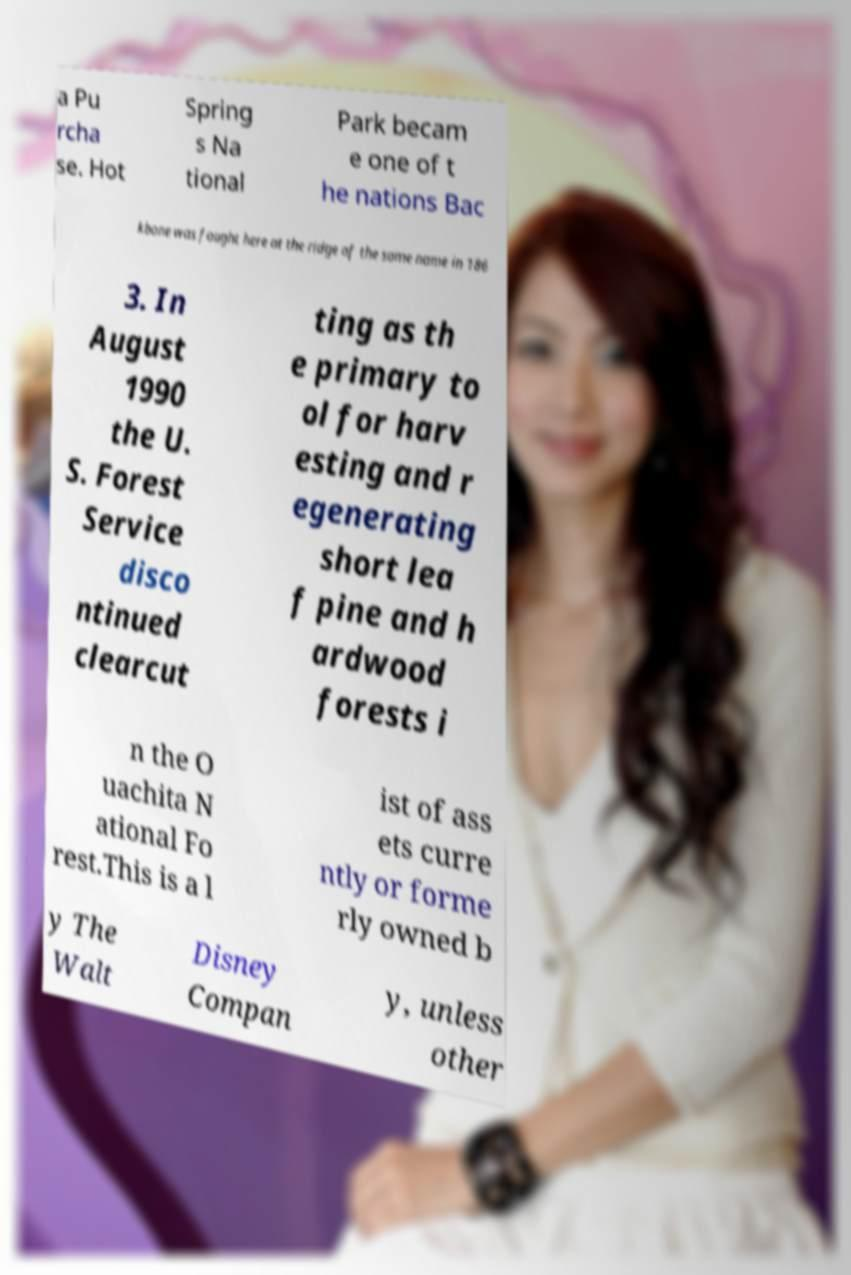Could you extract and type out the text from this image? a Pu rcha se. Hot Spring s Na tional Park becam e one of t he nations Bac kbone was fought here at the ridge of the same name in 186 3. In August 1990 the U. S. Forest Service disco ntinued clearcut ting as th e primary to ol for harv esting and r egenerating short lea f pine and h ardwood forests i n the O uachita N ational Fo rest.This is a l ist of ass ets curre ntly or forme rly owned b y The Walt Disney Compan y, unless other 